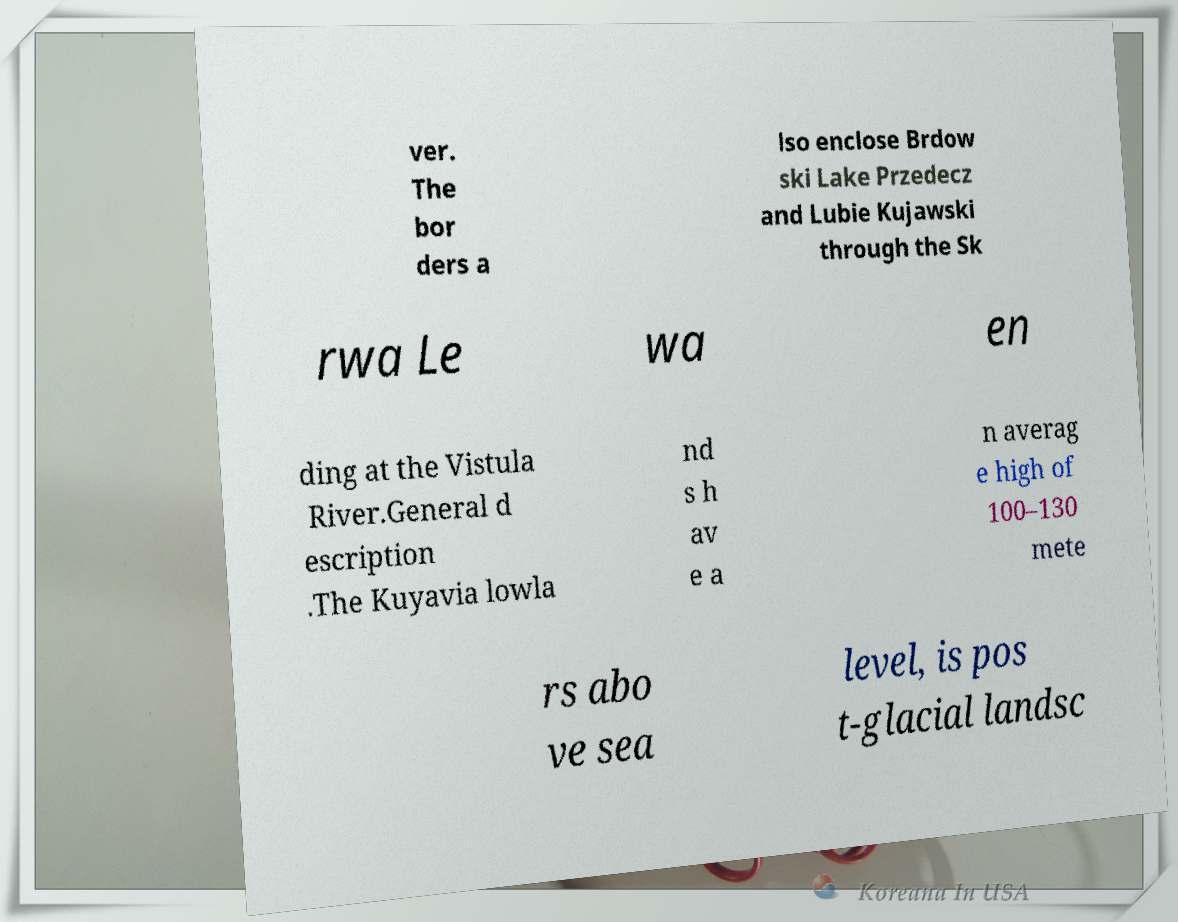Please read and relay the text visible in this image. What does it say? ver. The bor ders a lso enclose Brdow ski Lake Przedecz and Lubie Kujawski through the Sk rwa Le wa en ding at the Vistula River.General d escription .The Kuyavia lowla nd s h av e a n averag e high of 100–130 mete rs abo ve sea level, is pos t-glacial landsc 